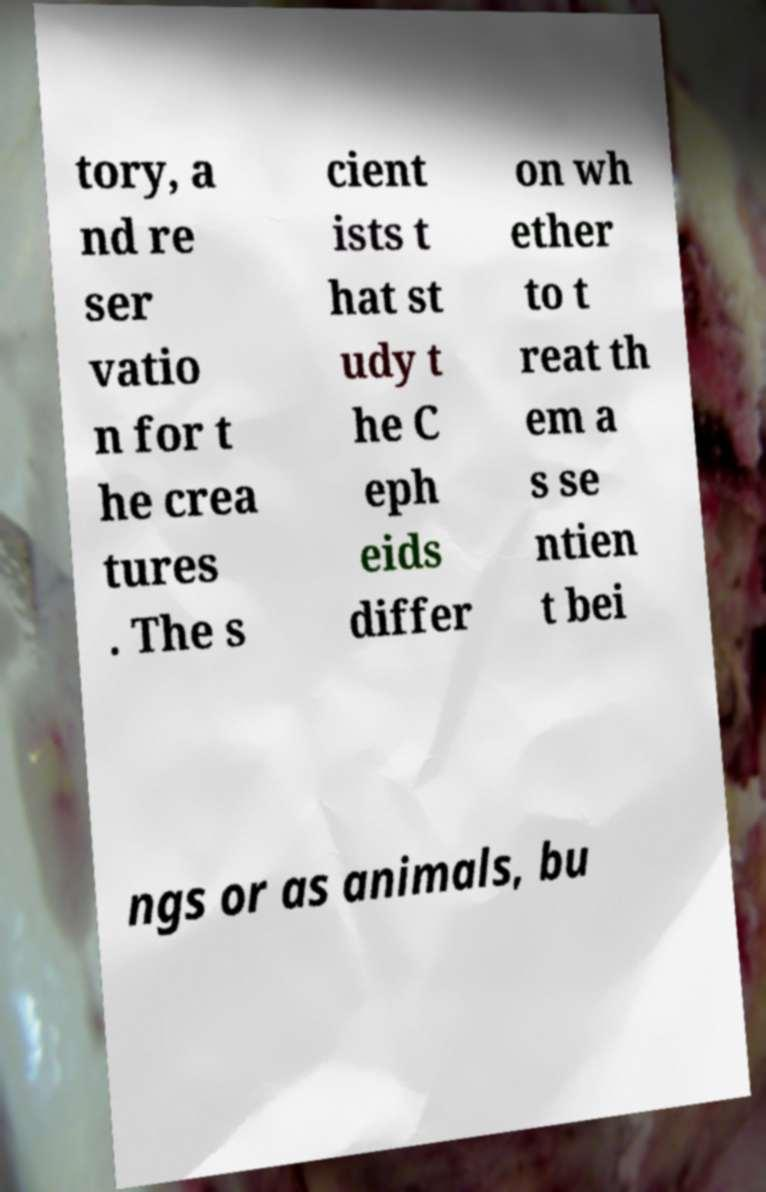Could you extract and type out the text from this image? tory, a nd re ser vatio n for t he crea tures . The s cient ists t hat st udy t he C eph eids differ on wh ether to t reat th em a s se ntien t bei ngs or as animals, bu 